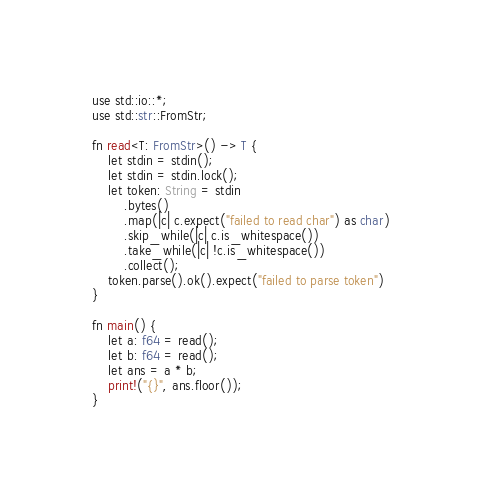Convert code to text. <code><loc_0><loc_0><loc_500><loc_500><_Rust_>use std::io::*;
use std::str::FromStr;

fn read<T: FromStr>() -> T {
    let stdin = stdin();
    let stdin = stdin.lock();
    let token: String = stdin
        .bytes()
        .map(|c| c.expect("failed to read char") as char)
        .skip_while(|c| c.is_whitespace())
        .take_while(|c| !c.is_whitespace())
        .collect();
    token.parse().ok().expect("failed to parse token")
}

fn main() {
    let a: f64 = read();
    let b: f64 = read();
    let ans = a * b;
    print!("{}", ans.floor());
}
</code> 